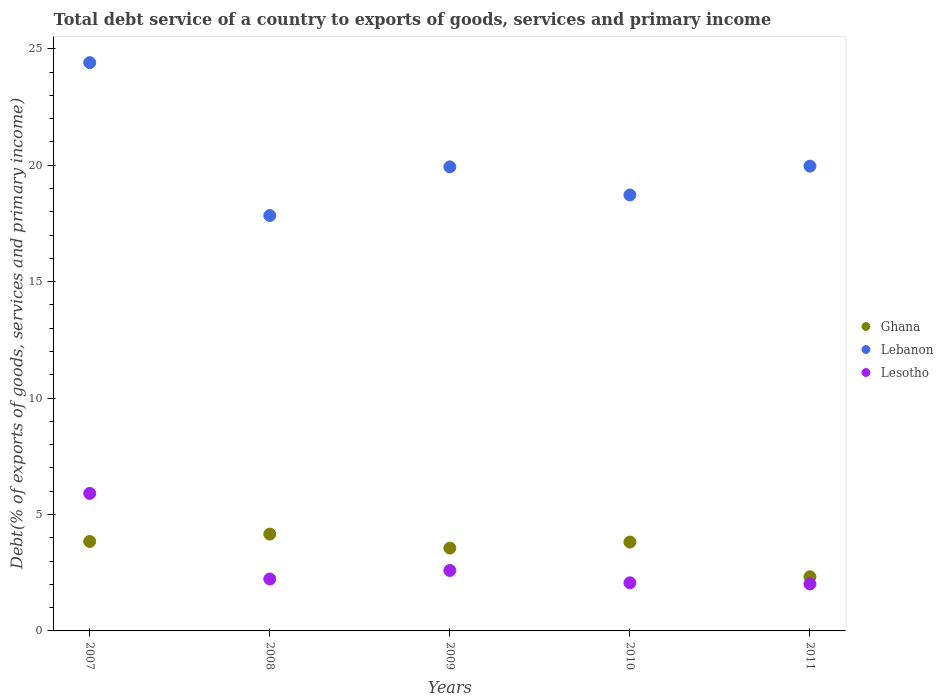How many different coloured dotlines are there?
Ensure brevity in your answer.  3. Is the number of dotlines equal to the number of legend labels?
Your response must be concise. Yes. What is the total debt service in Lesotho in 2009?
Provide a succinct answer. 2.6. Across all years, what is the maximum total debt service in Ghana?
Make the answer very short. 4.16. Across all years, what is the minimum total debt service in Lebanon?
Provide a short and direct response. 17.84. What is the total total debt service in Ghana in the graph?
Your answer should be very brief. 17.7. What is the difference between the total debt service in Ghana in 2010 and that in 2011?
Offer a terse response. 1.49. What is the difference between the total debt service in Ghana in 2007 and the total debt service in Lebanon in 2010?
Offer a terse response. -14.88. What is the average total debt service in Ghana per year?
Ensure brevity in your answer.  3.54. In the year 2011, what is the difference between the total debt service in Lesotho and total debt service in Ghana?
Your answer should be very brief. -0.31. What is the ratio of the total debt service in Ghana in 2007 to that in 2008?
Offer a terse response. 0.92. Is the difference between the total debt service in Lesotho in 2008 and 2011 greater than the difference between the total debt service in Ghana in 2008 and 2011?
Ensure brevity in your answer.  No. What is the difference between the highest and the second highest total debt service in Lesotho?
Offer a terse response. 3.31. What is the difference between the highest and the lowest total debt service in Lesotho?
Offer a terse response. 3.89. In how many years, is the total debt service in Ghana greater than the average total debt service in Ghana taken over all years?
Keep it short and to the point. 4. Is the total debt service in Lebanon strictly greater than the total debt service in Lesotho over the years?
Offer a terse response. Yes. Is the total debt service in Lebanon strictly less than the total debt service in Lesotho over the years?
Keep it short and to the point. No. How many dotlines are there?
Provide a succinct answer. 3. How many years are there in the graph?
Your answer should be very brief. 5. Are the values on the major ticks of Y-axis written in scientific E-notation?
Make the answer very short. No. Does the graph contain any zero values?
Your answer should be very brief. No. Where does the legend appear in the graph?
Provide a short and direct response. Center right. What is the title of the graph?
Provide a short and direct response. Total debt service of a country to exports of goods, services and primary income. Does "Jordan" appear as one of the legend labels in the graph?
Keep it short and to the point. No. What is the label or title of the Y-axis?
Keep it short and to the point. Debt(% of exports of goods, services and primary income). What is the Debt(% of exports of goods, services and primary income) of Ghana in 2007?
Keep it short and to the point. 3.84. What is the Debt(% of exports of goods, services and primary income) of Lebanon in 2007?
Make the answer very short. 24.41. What is the Debt(% of exports of goods, services and primary income) of Lesotho in 2007?
Provide a succinct answer. 5.9. What is the Debt(% of exports of goods, services and primary income) in Ghana in 2008?
Ensure brevity in your answer.  4.16. What is the Debt(% of exports of goods, services and primary income) in Lebanon in 2008?
Give a very brief answer. 17.84. What is the Debt(% of exports of goods, services and primary income) of Lesotho in 2008?
Give a very brief answer. 2.23. What is the Debt(% of exports of goods, services and primary income) of Ghana in 2009?
Provide a short and direct response. 3.56. What is the Debt(% of exports of goods, services and primary income) in Lebanon in 2009?
Your answer should be compact. 19.93. What is the Debt(% of exports of goods, services and primary income) of Lesotho in 2009?
Offer a terse response. 2.6. What is the Debt(% of exports of goods, services and primary income) of Ghana in 2010?
Your answer should be very brief. 3.82. What is the Debt(% of exports of goods, services and primary income) in Lebanon in 2010?
Keep it short and to the point. 18.72. What is the Debt(% of exports of goods, services and primary income) of Lesotho in 2010?
Your answer should be compact. 2.07. What is the Debt(% of exports of goods, services and primary income) of Ghana in 2011?
Provide a succinct answer. 2.33. What is the Debt(% of exports of goods, services and primary income) in Lebanon in 2011?
Make the answer very short. 19.96. What is the Debt(% of exports of goods, services and primary income) of Lesotho in 2011?
Your answer should be very brief. 2.02. Across all years, what is the maximum Debt(% of exports of goods, services and primary income) in Ghana?
Ensure brevity in your answer.  4.16. Across all years, what is the maximum Debt(% of exports of goods, services and primary income) in Lebanon?
Provide a succinct answer. 24.41. Across all years, what is the maximum Debt(% of exports of goods, services and primary income) in Lesotho?
Offer a very short reply. 5.9. Across all years, what is the minimum Debt(% of exports of goods, services and primary income) in Ghana?
Offer a very short reply. 2.33. Across all years, what is the minimum Debt(% of exports of goods, services and primary income) of Lebanon?
Your response must be concise. 17.84. Across all years, what is the minimum Debt(% of exports of goods, services and primary income) of Lesotho?
Your answer should be very brief. 2.02. What is the total Debt(% of exports of goods, services and primary income) of Ghana in the graph?
Make the answer very short. 17.7. What is the total Debt(% of exports of goods, services and primary income) in Lebanon in the graph?
Ensure brevity in your answer.  100.86. What is the total Debt(% of exports of goods, services and primary income) in Lesotho in the graph?
Make the answer very short. 14.82. What is the difference between the Debt(% of exports of goods, services and primary income) of Ghana in 2007 and that in 2008?
Offer a terse response. -0.32. What is the difference between the Debt(% of exports of goods, services and primary income) in Lebanon in 2007 and that in 2008?
Give a very brief answer. 6.57. What is the difference between the Debt(% of exports of goods, services and primary income) of Lesotho in 2007 and that in 2008?
Ensure brevity in your answer.  3.67. What is the difference between the Debt(% of exports of goods, services and primary income) in Ghana in 2007 and that in 2009?
Offer a very short reply. 0.28. What is the difference between the Debt(% of exports of goods, services and primary income) in Lebanon in 2007 and that in 2009?
Provide a short and direct response. 4.48. What is the difference between the Debt(% of exports of goods, services and primary income) in Lesotho in 2007 and that in 2009?
Provide a succinct answer. 3.31. What is the difference between the Debt(% of exports of goods, services and primary income) of Ghana in 2007 and that in 2010?
Your response must be concise. 0.03. What is the difference between the Debt(% of exports of goods, services and primary income) in Lebanon in 2007 and that in 2010?
Your answer should be compact. 5.68. What is the difference between the Debt(% of exports of goods, services and primary income) of Lesotho in 2007 and that in 2010?
Provide a short and direct response. 3.84. What is the difference between the Debt(% of exports of goods, services and primary income) in Ghana in 2007 and that in 2011?
Your response must be concise. 1.52. What is the difference between the Debt(% of exports of goods, services and primary income) in Lebanon in 2007 and that in 2011?
Your response must be concise. 4.45. What is the difference between the Debt(% of exports of goods, services and primary income) of Lesotho in 2007 and that in 2011?
Offer a terse response. 3.89. What is the difference between the Debt(% of exports of goods, services and primary income) of Ghana in 2008 and that in 2009?
Provide a short and direct response. 0.6. What is the difference between the Debt(% of exports of goods, services and primary income) of Lebanon in 2008 and that in 2009?
Provide a succinct answer. -2.09. What is the difference between the Debt(% of exports of goods, services and primary income) of Lesotho in 2008 and that in 2009?
Offer a very short reply. -0.37. What is the difference between the Debt(% of exports of goods, services and primary income) in Ghana in 2008 and that in 2010?
Offer a terse response. 0.34. What is the difference between the Debt(% of exports of goods, services and primary income) of Lebanon in 2008 and that in 2010?
Keep it short and to the point. -0.88. What is the difference between the Debt(% of exports of goods, services and primary income) of Lesotho in 2008 and that in 2010?
Your response must be concise. 0.16. What is the difference between the Debt(% of exports of goods, services and primary income) of Ghana in 2008 and that in 2011?
Provide a succinct answer. 1.83. What is the difference between the Debt(% of exports of goods, services and primary income) in Lebanon in 2008 and that in 2011?
Your response must be concise. -2.12. What is the difference between the Debt(% of exports of goods, services and primary income) of Lesotho in 2008 and that in 2011?
Your response must be concise. 0.21. What is the difference between the Debt(% of exports of goods, services and primary income) in Ghana in 2009 and that in 2010?
Offer a very short reply. -0.26. What is the difference between the Debt(% of exports of goods, services and primary income) in Lebanon in 2009 and that in 2010?
Provide a succinct answer. 1.21. What is the difference between the Debt(% of exports of goods, services and primary income) of Lesotho in 2009 and that in 2010?
Offer a very short reply. 0.53. What is the difference between the Debt(% of exports of goods, services and primary income) of Ghana in 2009 and that in 2011?
Give a very brief answer. 1.23. What is the difference between the Debt(% of exports of goods, services and primary income) in Lebanon in 2009 and that in 2011?
Offer a very short reply. -0.03. What is the difference between the Debt(% of exports of goods, services and primary income) of Lesotho in 2009 and that in 2011?
Your response must be concise. 0.58. What is the difference between the Debt(% of exports of goods, services and primary income) in Ghana in 2010 and that in 2011?
Make the answer very short. 1.49. What is the difference between the Debt(% of exports of goods, services and primary income) in Lebanon in 2010 and that in 2011?
Provide a succinct answer. -1.24. What is the difference between the Debt(% of exports of goods, services and primary income) in Lesotho in 2010 and that in 2011?
Your answer should be compact. 0.05. What is the difference between the Debt(% of exports of goods, services and primary income) in Ghana in 2007 and the Debt(% of exports of goods, services and primary income) in Lebanon in 2008?
Keep it short and to the point. -14. What is the difference between the Debt(% of exports of goods, services and primary income) in Ghana in 2007 and the Debt(% of exports of goods, services and primary income) in Lesotho in 2008?
Your answer should be compact. 1.61. What is the difference between the Debt(% of exports of goods, services and primary income) in Lebanon in 2007 and the Debt(% of exports of goods, services and primary income) in Lesotho in 2008?
Your answer should be very brief. 22.18. What is the difference between the Debt(% of exports of goods, services and primary income) of Ghana in 2007 and the Debt(% of exports of goods, services and primary income) of Lebanon in 2009?
Keep it short and to the point. -16.09. What is the difference between the Debt(% of exports of goods, services and primary income) in Ghana in 2007 and the Debt(% of exports of goods, services and primary income) in Lesotho in 2009?
Your answer should be very brief. 1.25. What is the difference between the Debt(% of exports of goods, services and primary income) in Lebanon in 2007 and the Debt(% of exports of goods, services and primary income) in Lesotho in 2009?
Keep it short and to the point. 21.81. What is the difference between the Debt(% of exports of goods, services and primary income) in Ghana in 2007 and the Debt(% of exports of goods, services and primary income) in Lebanon in 2010?
Your answer should be compact. -14.88. What is the difference between the Debt(% of exports of goods, services and primary income) of Ghana in 2007 and the Debt(% of exports of goods, services and primary income) of Lesotho in 2010?
Ensure brevity in your answer.  1.77. What is the difference between the Debt(% of exports of goods, services and primary income) of Lebanon in 2007 and the Debt(% of exports of goods, services and primary income) of Lesotho in 2010?
Give a very brief answer. 22.34. What is the difference between the Debt(% of exports of goods, services and primary income) in Ghana in 2007 and the Debt(% of exports of goods, services and primary income) in Lebanon in 2011?
Your response must be concise. -16.12. What is the difference between the Debt(% of exports of goods, services and primary income) in Ghana in 2007 and the Debt(% of exports of goods, services and primary income) in Lesotho in 2011?
Make the answer very short. 1.82. What is the difference between the Debt(% of exports of goods, services and primary income) in Lebanon in 2007 and the Debt(% of exports of goods, services and primary income) in Lesotho in 2011?
Keep it short and to the point. 22.39. What is the difference between the Debt(% of exports of goods, services and primary income) of Ghana in 2008 and the Debt(% of exports of goods, services and primary income) of Lebanon in 2009?
Give a very brief answer. -15.77. What is the difference between the Debt(% of exports of goods, services and primary income) of Ghana in 2008 and the Debt(% of exports of goods, services and primary income) of Lesotho in 2009?
Provide a short and direct response. 1.56. What is the difference between the Debt(% of exports of goods, services and primary income) of Lebanon in 2008 and the Debt(% of exports of goods, services and primary income) of Lesotho in 2009?
Provide a short and direct response. 15.24. What is the difference between the Debt(% of exports of goods, services and primary income) in Ghana in 2008 and the Debt(% of exports of goods, services and primary income) in Lebanon in 2010?
Your answer should be compact. -14.57. What is the difference between the Debt(% of exports of goods, services and primary income) in Ghana in 2008 and the Debt(% of exports of goods, services and primary income) in Lesotho in 2010?
Provide a succinct answer. 2.09. What is the difference between the Debt(% of exports of goods, services and primary income) of Lebanon in 2008 and the Debt(% of exports of goods, services and primary income) of Lesotho in 2010?
Provide a succinct answer. 15.77. What is the difference between the Debt(% of exports of goods, services and primary income) in Ghana in 2008 and the Debt(% of exports of goods, services and primary income) in Lebanon in 2011?
Your response must be concise. -15.8. What is the difference between the Debt(% of exports of goods, services and primary income) in Ghana in 2008 and the Debt(% of exports of goods, services and primary income) in Lesotho in 2011?
Your answer should be very brief. 2.14. What is the difference between the Debt(% of exports of goods, services and primary income) in Lebanon in 2008 and the Debt(% of exports of goods, services and primary income) in Lesotho in 2011?
Your response must be concise. 15.82. What is the difference between the Debt(% of exports of goods, services and primary income) of Ghana in 2009 and the Debt(% of exports of goods, services and primary income) of Lebanon in 2010?
Ensure brevity in your answer.  -15.17. What is the difference between the Debt(% of exports of goods, services and primary income) in Ghana in 2009 and the Debt(% of exports of goods, services and primary income) in Lesotho in 2010?
Your answer should be compact. 1.49. What is the difference between the Debt(% of exports of goods, services and primary income) of Lebanon in 2009 and the Debt(% of exports of goods, services and primary income) of Lesotho in 2010?
Keep it short and to the point. 17.86. What is the difference between the Debt(% of exports of goods, services and primary income) in Ghana in 2009 and the Debt(% of exports of goods, services and primary income) in Lebanon in 2011?
Keep it short and to the point. -16.4. What is the difference between the Debt(% of exports of goods, services and primary income) of Ghana in 2009 and the Debt(% of exports of goods, services and primary income) of Lesotho in 2011?
Your answer should be compact. 1.54. What is the difference between the Debt(% of exports of goods, services and primary income) of Lebanon in 2009 and the Debt(% of exports of goods, services and primary income) of Lesotho in 2011?
Provide a short and direct response. 17.91. What is the difference between the Debt(% of exports of goods, services and primary income) of Ghana in 2010 and the Debt(% of exports of goods, services and primary income) of Lebanon in 2011?
Ensure brevity in your answer.  -16.15. What is the difference between the Debt(% of exports of goods, services and primary income) of Ghana in 2010 and the Debt(% of exports of goods, services and primary income) of Lesotho in 2011?
Provide a short and direct response. 1.8. What is the difference between the Debt(% of exports of goods, services and primary income) of Lebanon in 2010 and the Debt(% of exports of goods, services and primary income) of Lesotho in 2011?
Give a very brief answer. 16.71. What is the average Debt(% of exports of goods, services and primary income) of Ghana per year?
Keep it short and to the point. 3.54. What is the average Debt(% of exports of goods, services and primary income) in Lebanon per year?
Your answer should be very brief. 20.17. What is the average Debt(% of exports of goods, services and primary income) in Lesotho per year?
Provide a succinct answer. 2.96. In the year 2007, what is the difference between the Debt(% of exports of goods, services and primary income) of Ghana and Debt(% of exports of goods, services and primary income) of Lebanon?
Your response must be concise. -20.57. In the year 2007, what is the difference between the Debt(% of exports of goods, services and primary income) in Ghana and Debt(% of exports of goods, services and primary income) in Lesotho?
Make the answer very short. -2.06. In the year 2007, what is the difference between the Debt(% of exports of goods, services and primary income) of Lebanon and Debt(% of exports of goods, services and primary income) of Lesotho?
Keep it short and to the point. 18.5. In the year 2008, what is the difference between the Debt(% of exports of goods, services and primary income) of Ghana and Debt(% of exports of goods, services and primary income) of Lebanon?
Offer a terse response. -13.68. In the year 2008, what is the difference between the Debt(% of exports of goods, services and primary income) of Ghana and Debt(% of exports of goods, services and primary income) of Lesotho?
Provide a succinct answer. 1.93. In the year 2008, what is the difference between the Debt(% of exports of goods, services and primary income) in Lebanon and Debt(% of exports of goods, services and primary income) in Lesotho?
Your answer should be very brief. 15.61. In the year 2009, what is the difference between the Debt(% of exports of goods, services and primary income) of Ghana and Debt(% of exports of goods, services and primary income) of Lebanon?
Provide a succinct answer. -16.37. In the year 2009, what is the difference between the Debt(% of exports of goods, services and primary income) of Ghana and Debt(% of exports of goods, services and primary income) of Lesotho?
Provide a succinct answer. 0.96. In the year 2009, what is the difference between the Debt(% of exports of goods, services and primary income) in Lebanon and Debt(% of exports of goods, services and primary income) in Lesotho?
Give a very brief answer. 17.33. In the year 2010, what is the difference between the Debt(% of exports of goods, services and primary income) in Ghana and Debt(% of exports of goods, services and primary income) in Lebanon?
Make the answer very short. -14.91. In the year 2010, what is the difference between the Debt(% of exports of goods, services and primary income) in Ghana and Debt(% of exports of goods, services and primary income) in Lesotho?
Offer a very short reply. 1.75. In the year 2010, what is the difference between the Debt(% of exports of goods, services and primary income) of Lebanon and Debt(% of exports of goods, services and primary income) of Lesotho?
Provide a succinct answer. 16.66. In the year 2011, what is the difference between the Debt(% of exports of goods, services and primary income) of Ghana and Debt(% of exports of goods, services and primary income) of Lebanon?
Provide a succinct answer. -17.64. In the year 2011, what is the difference between the Debt(% of exports of goods, services and primary income) of Ghana and Debt(% of exports of goods, services and primary income) of Lesotho?
Offer a very short reply. 0.31. In the year 2011, what is the difference between the Debt(% of exports of goods, services and primary income) of Lebanon and Debt(% of exports of goods, services and primary income) of Lesotho?
Provide a succinct answer. 17.94. What is the ratio of the Debt(% of exports of goods, services and primary income) in Ghana in 2007 to that in 2008?
Offer a very short reply. 0.92. What is the ratio of the Debt(% of exports of goods, services and primary income) of Lebanon in 2007 to that in 2008?
Offer a very short reply. 1.37. What is the ratio of the Debt(% of exports of goods, services and primary income) of Lesotho in 2007 to that in 2008?
Offer a terse response. 2.65. What is the ratio of the Debt(% of exports of goods, services and primary income) of Ghana in 2007 to that in 2009?
Give a very brief answer. 1.08. What is the ratio of the Debt(% of exports of goods, services and primary income) in Lebanon in 2007 to that in 2009?
Your answer should be very brief. 1.22. What is the ratio of the Debt(% of exports of goods, services and primary income) in Lesotho in 2007 to that in 2009?
Your answer should be compact. 2.27. What is the ratio of the Debt(% of exports of goods, services and primary income) in Ghana in 2007 to that in 2010?
Provide a succinct answer. 1.01. What is the ratio of the Debt(% of exports of goods, services and primary income) of Lebanon in 2007 to that in 2010?
Offer a very short reply. 1.3. What is the ratio of the Debt(% of exports of goods, services and primary income) in Lesotho in 2007 to that in 2010?
Make the answer very short. 2.86. What is the ratio of the Debt(% of exports of goods, services and primary income) of Ghana in 2007 to that in 2011?
Make the answer very short. 1.65. What is the ratio of the Debt(% of exports of goods, services and primary income) in Lebanon in 2007 to that in 2011?
Provide a short and direct response. 1.22. What is the ratio of the Debt(% of exports of goods, services and primary income) of Lesotho in 2007 to that in 2011?
Provide a succinct answer. 2.93. What is the ratio of the Debt(% of exports of goods, services and primary income) of Ghana in 2008 to that in 2009?
Offer a terse response. 1.17. What is the ratio of the Debt(% of exports of goods, services and primary income) in Lebanon in 2008 to that in 2009?
Provide a succinct answer. 0.9. What is the ratio of the Debt(% of exports of goods, services and primary income) in Lesotho in 2008 to that in 2009?
Ensure brevity in your answer.  0.86. What is the ratio of the Debt(% of exports of goods, services and primary income) in Ghana in 2008 to that in 2010?
Make the answer very short. 1.09. What is the ratio of the Debt(% of exports of goods, services and primary income) in Lebanon in 2008 to that in 2010?
Give a very brief answer. 0.95. What is the ratio of the Debt(% of exports of goods, services and primary income) of Lesotho in 2008 to that in 2010?
Offer a terse response. 1.08. What is the ratio of the Debt(% of exports of goods, services and primary income) of Ghana in 2008 to that in 2011?
Make the answer very short. 1.79. What is the ratio of the Debt(% of exports of goods, services and primary income) of Lebanon in 2008 to that in 2011?
Offer a very short reply. 0.89. What is the ratio of the Debt(% of exports of goods, services and primary income) of Lesotho in 2008 to that in 2011?
Your answer should be very brief. 1.11. What is the ratio of the Debt(% of exports of goods, services and primary income) in Ghana in 2009 to that in 2010?
Make the answer very short. 0.93. What is the ratio of the Debt(% of exports of goods, services and primary income) in Lebanon in 2009 to that in 2010?
Ensure brevity in your answer.  1.06. What is the ratio of the Debt(% of exports of goods, services and primary income) in Lesotho in 2009 to that in 2010?
Give a very brief answer. 1.26. What is the ratio of the Debt(% of exports of goods, services and primary income) in Ghana in 2009 to that in 2011?
Give a very brief answer. 1.53. What is the ratio of the Debt(% of exports of goods, services and primary income) of Lebanon in 2009 to that in 2011?
Keep it short and to the point. 1. What is the ratio of the Debt(% of exports of goods, services and primary income) of Lesotho in 2009 to that in 2011?
Offer a very short reply. 1.29. What is the ratio of the Debt(% of exports of goods, services and primary income) in Ghana in 2010 to that in 2011?
Your response must be concise. 1.64. What is the ratio of the Debt(% of exports of goods, services and primary income) of Lebanon in 2010 to that in 2011?
Give a very brief answer. 0.94. What is the ratio of the Debt(% of exports of goods, services and primary income) of Lesotho in 2010 to that in 2011?
Offer a very short reply. 1.02. What is the difference between the highest and the second highest Debt(% of exports of goods, services and primary income) of Ghana?
Your answer should be very brief. 0.32. What is the difference between the highest and the second highest Debt(% of exports of goods, services and primary income) of Lebanon?
Provide a short and direct response. 4.45. What is the difference between the highest and the second highest Debt(% of exports of goods, services and primary income) of Lesotho?
Ensure brevity in your answer.  3.31. What is the difference between the highest and the lowest Debt(% of exports of goods, services and primary income) in Ghana?
Your answer should be compact. 1.83. What is the difference between the highest and the lowest Debt(% of exports of goods, services and primary income) of Lebanon?
Your answer should be very brief. 6.57. What is the difference between the highest and the lowest Debt(% of exports of goods, services and primary income) in Lesotho?
Provide a short and direct response. 3.89. 